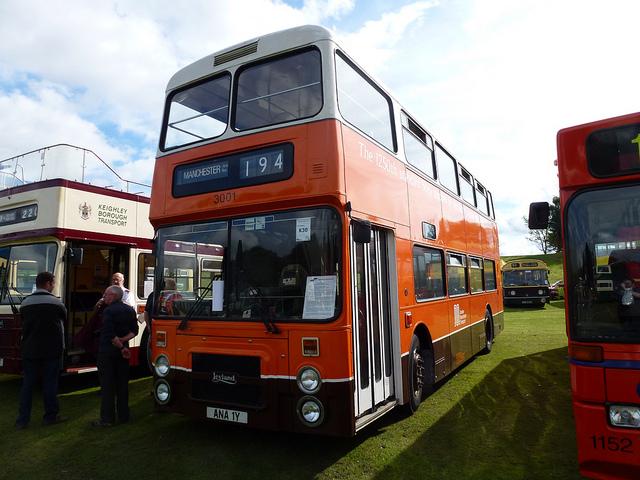What is the bus number?
Quick response, please. 194. Is anyone at the bus stop?
Short answer required. Yes. How many busses are there?
Quick response, please. 3. Are there any passengers visible on the bus?
Write a very short answer. No. What color is the bus?
Give a very brief answer. Orange. 